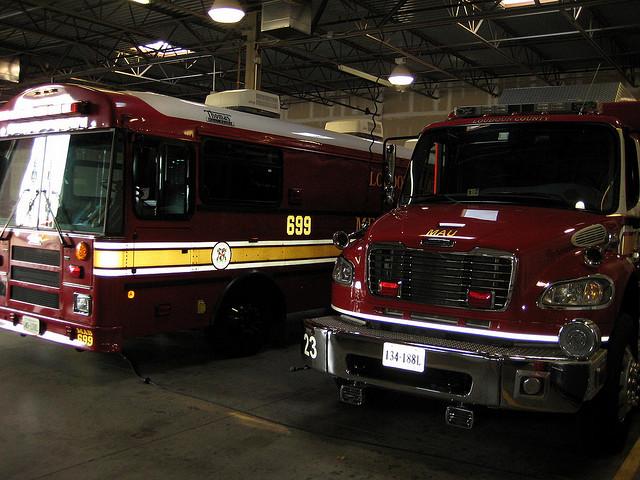Are these fire trucks?
Short answer required. Yes. What color is the stripe on the bus?
Be succinct. Yellow. Are there lights on?
Short answer required. Yes. 